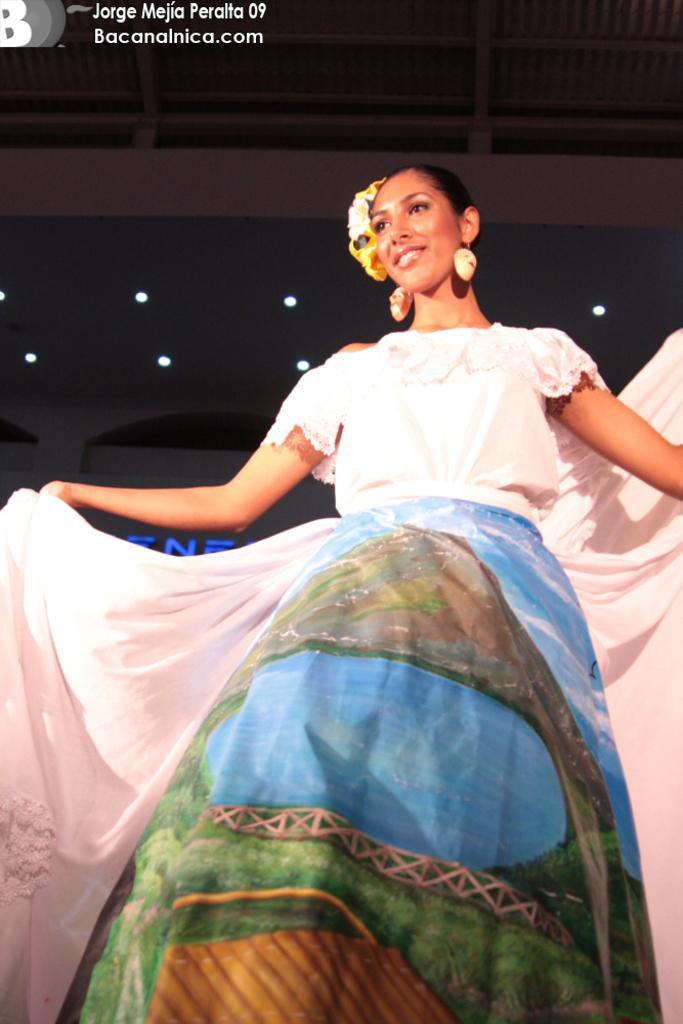Please provide a concise description of this image. In this image I can see a woman is standing, I can see she is wearing white and blue colour dress. I can also see smile on her face and in background I can see few lights. Here I can see watermark. 